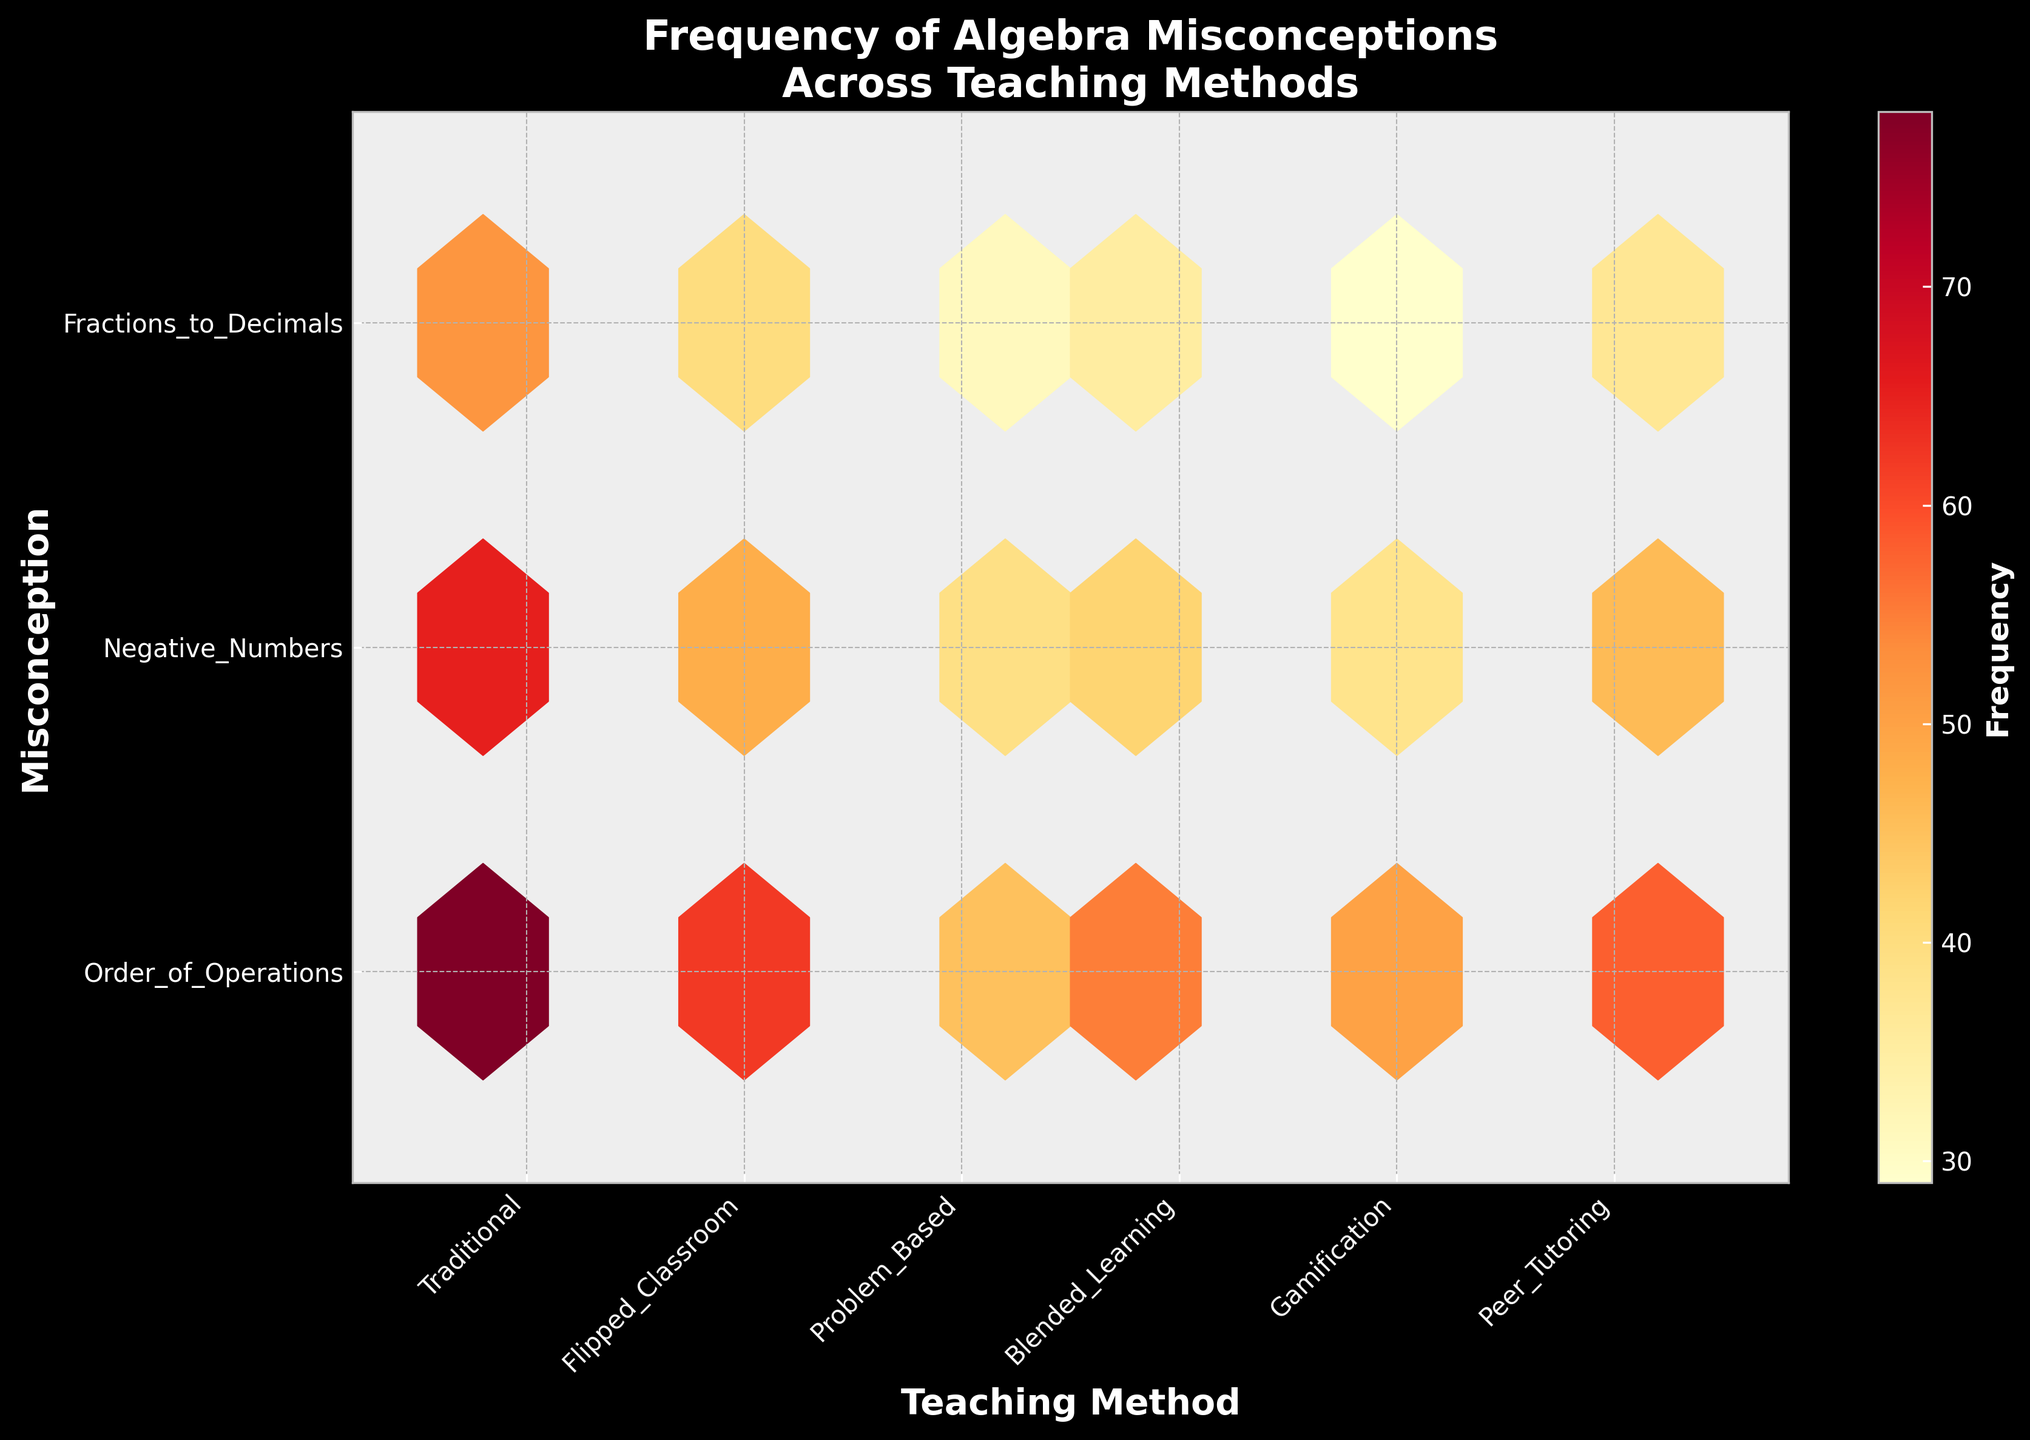What is the title of the figure? The figure's title is prominently displayed at the top. It states "Frequency of Algebra Misconceptions Across Teaching Methods".
Answer: Frequency of Algebra Misconceptions Across Teaching Methods How many teaching methods are represented in the plot? The x-axis shows the teaching methods labeled on the horizontal axis. Counting these labels gives the total number of teaching methods.
Answer: 6 What color represents the highest frequency in the hexbin plot? The color bar on the side indicates the frequency, with darker shades representing higher frequencies. The darkest shade on the plot corresponds to the highest frequency.
Answer: Dark red Which teaching method has the highest frequency of misconceptions for 'Order of Operations'? Locate the 'Order of Operations' row on the y-axis and find the darkest hexagon along the x-axis in that row. The corresponding teaching method will be on the x-axis.
Answer: Traditional Between 'Negative Numbers' and 'Fractions to Decimals', which misconception has the higher overall frequency in 'Flipped Classroom'? Compare the shades of hexagons in the 'Flipped Classroom' column for both misconceptions. The darker hexagon indicates the higher frequency.
Answer: Negative Numbers What is the median frequency for 'Gamification' across all misconceptions? Find the 'Gamification' column. The frequencies are 50, 38, and 29. Arrange these values as 29, 38, 50, and identify the middle value.
Answer: 38 Which teaching method shows the lowest frequency for 'Negative Numbers'? Look at the 'Negative Numbers' row and find the lightest hexagon. The teaching method corresponding to this hexagon on the x-axis indicates the lowest frequency.
Answer: Problem Based Is the frequency of 'Order of Operations' misconceptions in 'Peer Tutoring' greater than 'Blended Learning'? Compare the shades of the hexagons for 'Order of Operations' row in 'Peer Tutoring' and 'Blended Learning' columns. The darker hexagon means a higher frequency.
Answer: Yes What is the range of frequencies for 'Fractions to Decimals' misconception across all methods? Identify the lightest (minimum frequency) and darkest (maximum frequency) hexagons in the 'Fractions to Decimals' row and subtract the minimum frequency from the maximum frequency.
Answer: 52 - 29 = 23 